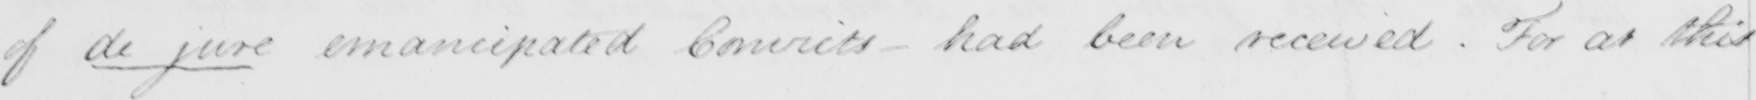What does this handwritten line say? of de jure emancipated Convicts - had been received . For at this 